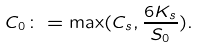<formula> <loc_0><loc_0><loc_500><loc_500>C _ { 0 } \colon = \max ( C _ { s } , \frac { 6 K _ { s } } { S _ { 0 } } ) .</formula> 